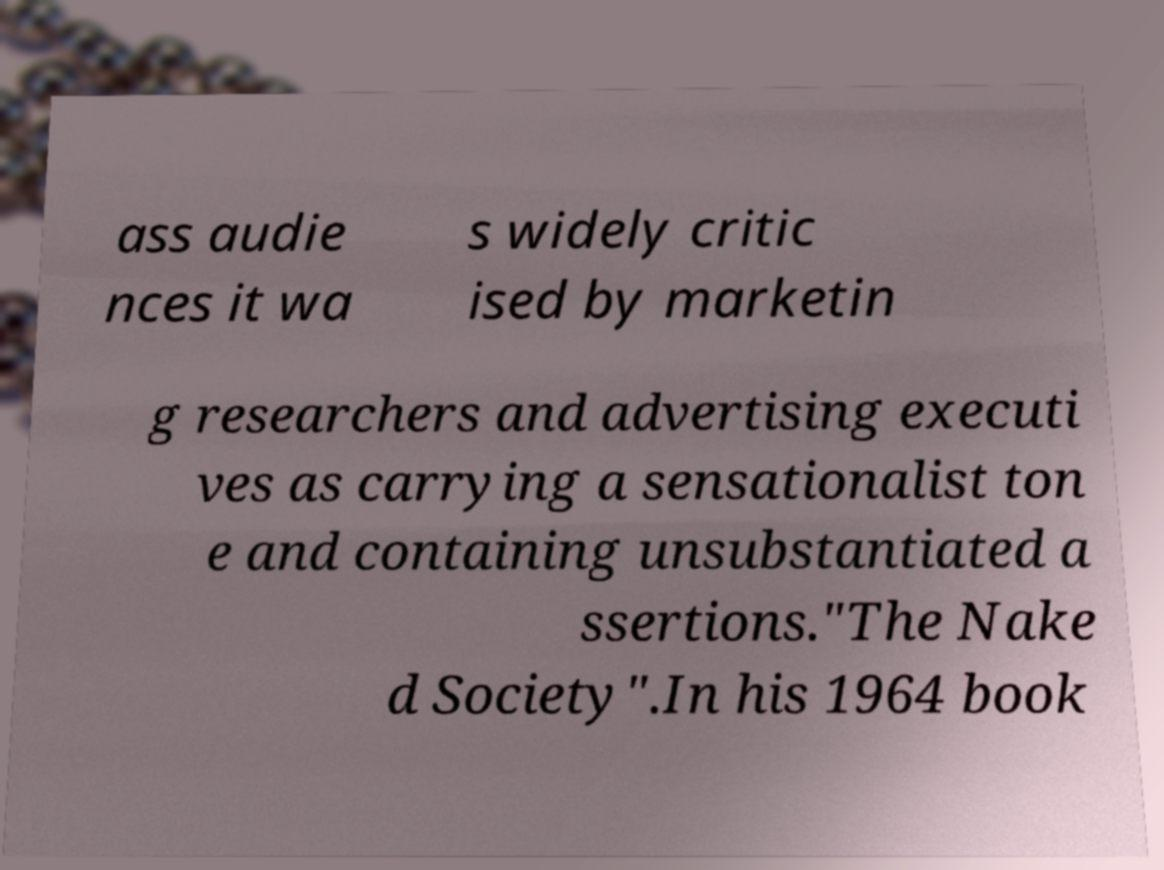For documentation purposes, I need the text within this image transcribed. Could you provide that? ass audie nces it wa s widely critic ised by marketin g researchers and advertising executi ves as carrying a sensationalist ton e and containing unsubstantiated a ssertions."The Nake d Society".In his 1964 book 